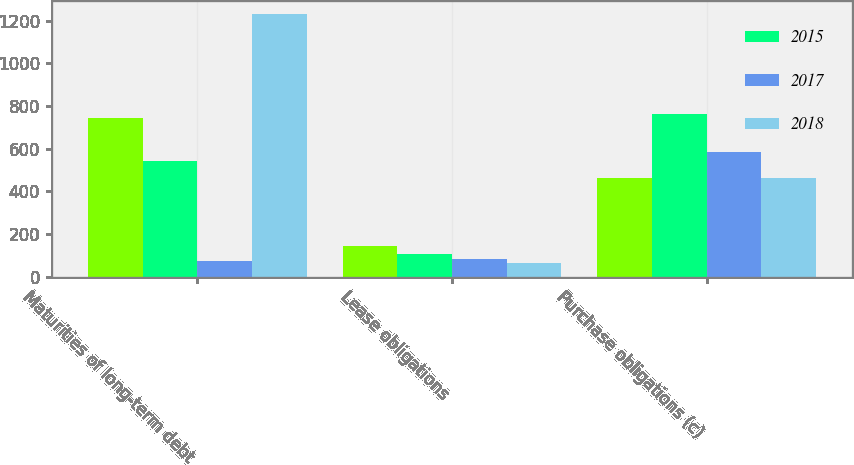<chart> <loc_0><loc_0><loc_500><loc_500><stacked_bar_chart><ecel><fcel>Maturities of long-term debt<fcel>Lease obligations<fcel>Purchase obligations (c)<nl><fcel>nan<fcel>742<fcel>142<fcel>463<nl><fcel>2015<fcel>543<fcel>106<fcel>761<nl><fcel>2017<fcel>71<fcel>84<fcel>583<nl><fcel>2018<fcel>1229<fcel>63<fcel>463<nl></chart> 